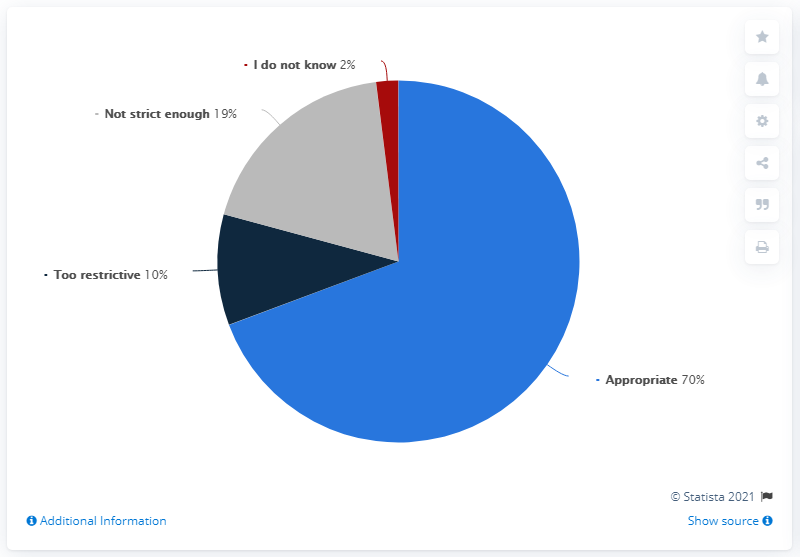Mention a couple of crucial points in this snapshot. The Finnish government's measures against the coronavirus are appropriate to the extent of 70%. The value of a smaller pizza is 2. 